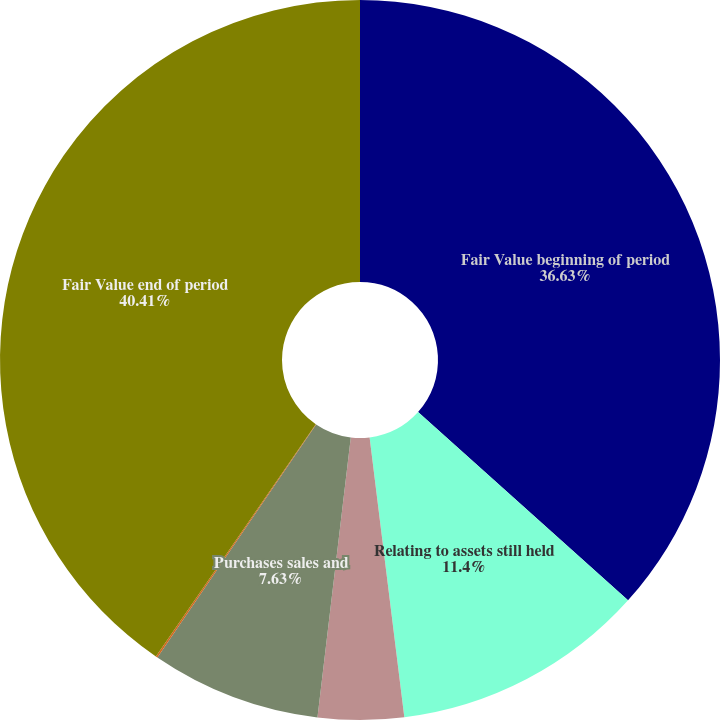<chart> <loc_0><loc_0><loc_500><loc_500><pie_chart><fcel>Fair Value beginning of period<fcel>Relating to assets still held<fcel>Relating to assets sold during<fcel>Purchases sales and<fcel>Transfers in and/or out of<fcel>Fair Value end of period<nl><fcel>36.63%<fcel>11.4%<fcel>3.85%<fcel>7.63%<fcel>0.08%<fcel>40.4%<nl></chart> 